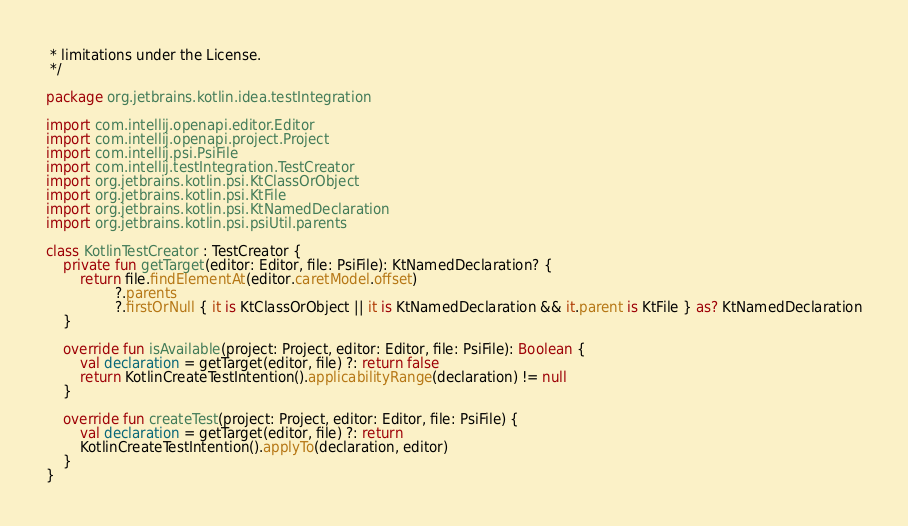<code> <loc_0><loc_0><loc_500><loc_500><_Kotlin_> * limitations under the License.
 */

package org.jetbrains.kotlin.idea.testIntegration

import com.intellij.openapi.editor.Editor
import com.intellij.openapi.project.Project
import com.intellij.psi.PsiFile
import com.intellij.testIntegration.TestCreator
import org.jetbrains.kotlin.psi.KtClassOrObject
import org.jetbrains.kotlin.psi.KtFile
import org.jetbrains.kotlin.psi.KtNamedDeclaration
import org.jetbrains.kotlin.psi.psiUtil.parents

class KotlinTestCreator : TestCreator {
    private fun getTarget(editor: Editor, file: PsiFile): KtNamedDeclaration? {
        return file.findElementAt(editor.caretModel.offset)
                ?.parents
                ?.firstOrNull { it is KtClassOrObject || it is KtNamedDeclaration && it.parent is KtFile } as? KtNamedDeclaration
    }

    override fun isAvailable(project: Project, editor: Editor, file: PsiFile): Boolean {
        val declaration = getTarget(editor, file) ?: return false
        return KotlinCreateTestIntention().applicabilityRange(declaration) != null
    }

    override fun createTest(project: Project, editor: Editor, file: PsiFile) {
        val declaration = getTarget(editor, file) ?: return
        KotlinCreateTestIntention().applyTo(declaration, editor)
    }
}</code> 